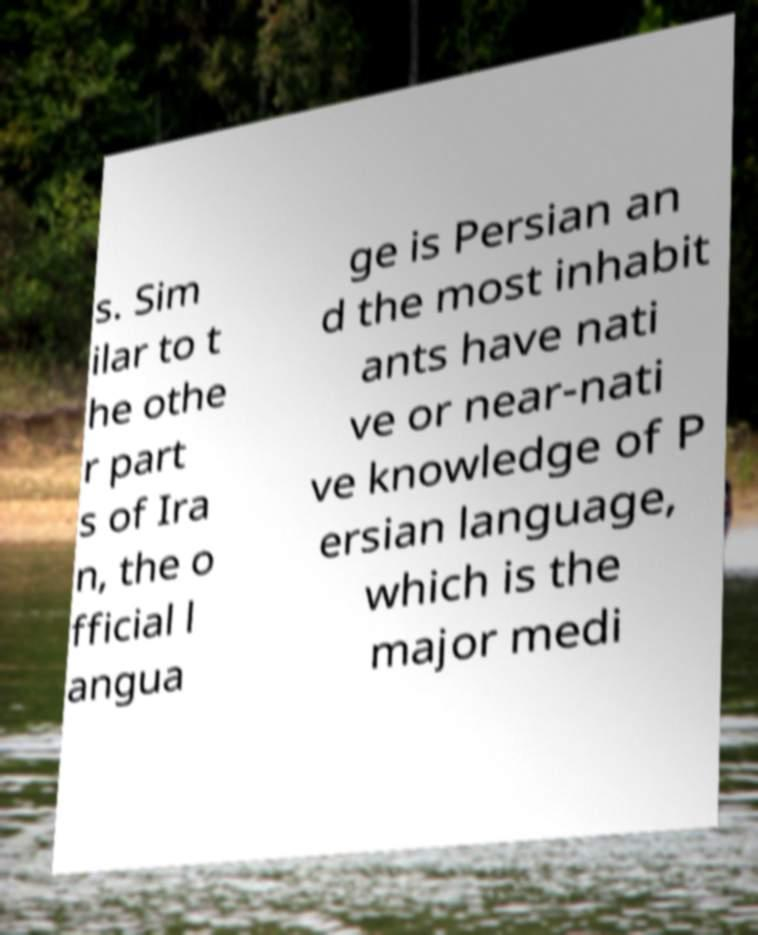I need the written content from this picture converted into text. Can you do that? s. Sim ilar to t he othe r part s of Ira n, the o fficial l angua ge is Persian an d the most inhabit ants have nati ve or near-nati ve knowledge of P ersian language, which is the major medi 